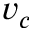<formula> <loc_0><loc_0><loc_500><loc_500>v _ { c }</formula> 